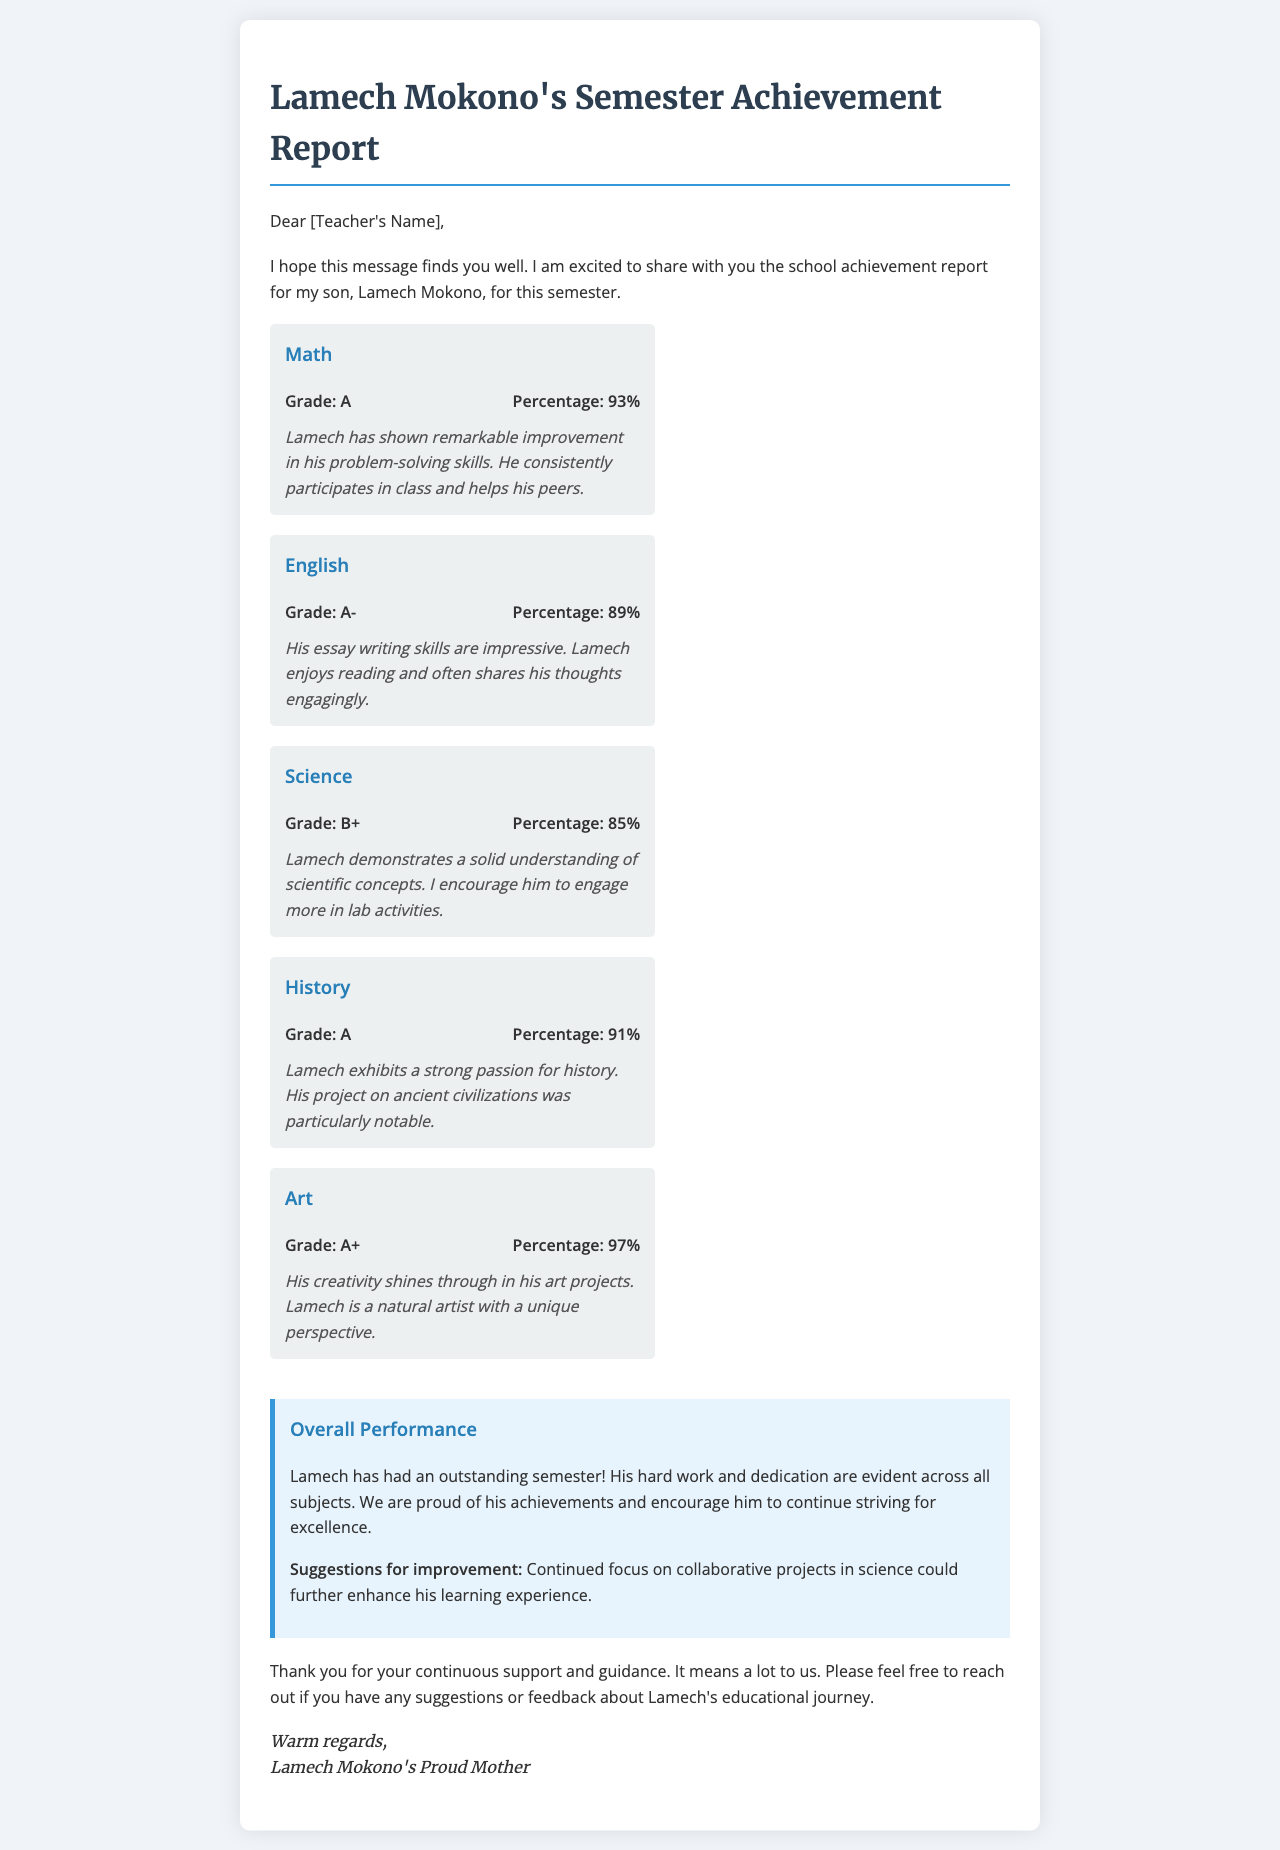What is Lamech's grade in Math? Lamech's grade in Math is stated in the document.
Answer: A What percentage did Lamech achieve in English? The document provides the percentage for each subject, including English.
Answer: 89% What general feedback did Lamech's teacher give for Science? The teacher feedback section for Science includes specific comments that summarize Lamech's performance.
Answer: Engage more in lab activities How is Lamech's performance in Art characterized? Art is one of the subjects listed, with feedback detailing Lamech's skills.
Answer: Natural artist with a unique perspective What is the overall sentiment regarding Lamech's semester performance? The overall performance section summarizes the sentiment towards Lamech’s achievements across subjects.
Answer: Outstanding semester How many subjects did Lamech receive an A or higher in? The grades section lists all subjects and Lamech’s grades for each, allowing for a count.
Answer: 4 What is suggested for improvement in Lamech's education? The document includes suggestions for improvement within the overall performance section.
Answer: Continued focus on collaborative projects in science Who is the sender of the report? The signature section of the document indicates who is sending the report.
Answer: Lamech Mokono's Proud Mother 